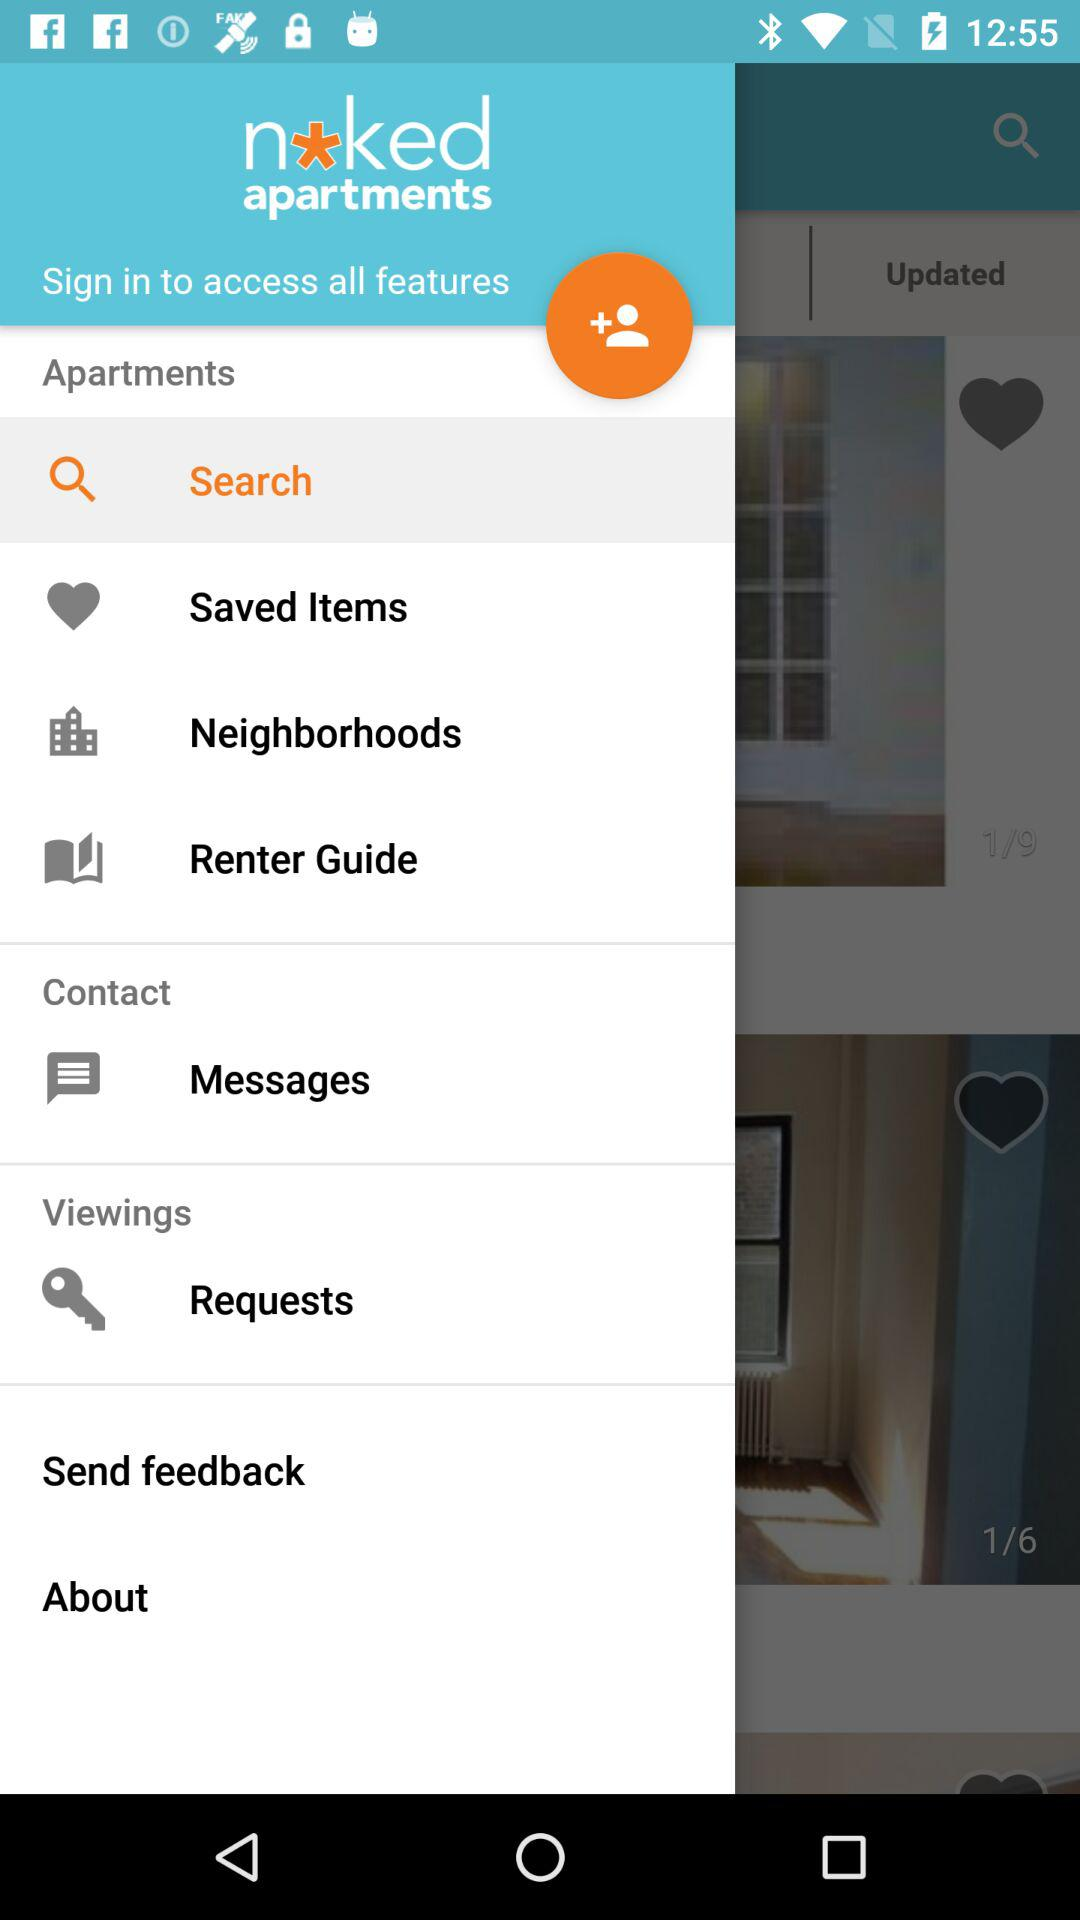What is the name of the application? The name of the application is "naked apartments". 